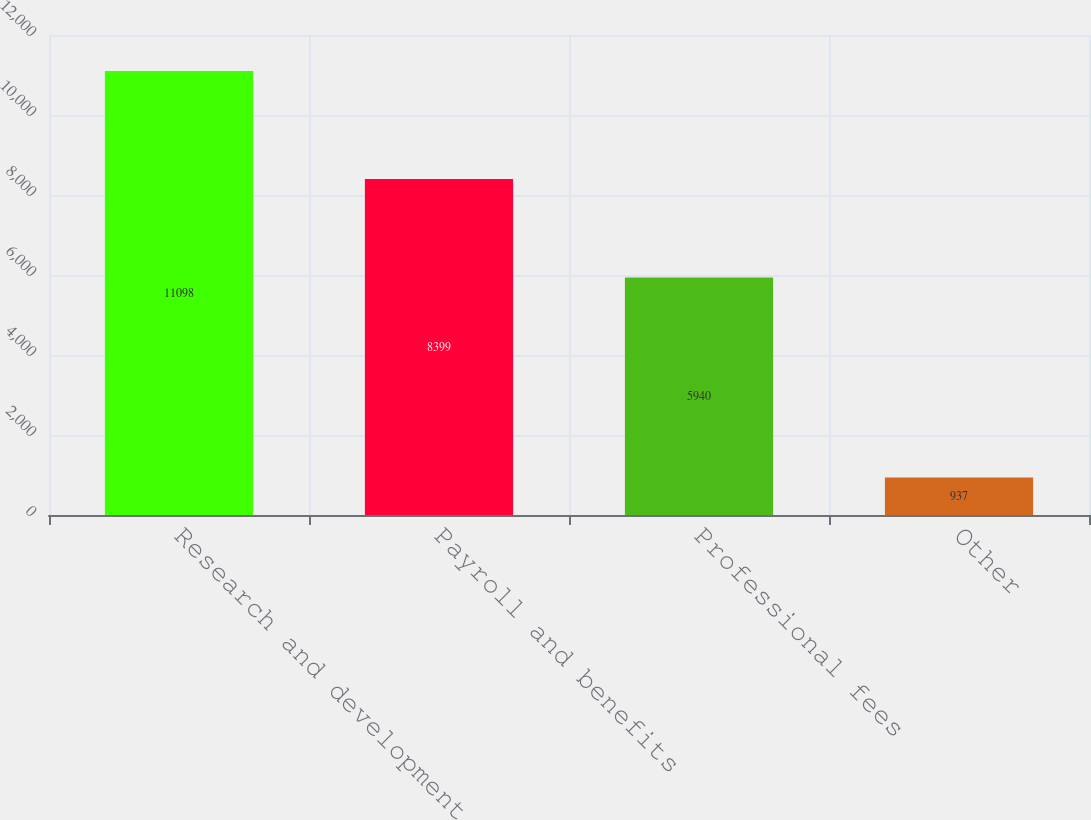Convert chart. <chart><loc_0><loc_0><loc_500><loc_500><bar_chart><fcel>Research and development<fcel>Payroll and benefits<fcel>Professional fees<fcel>Other<nl><fcel>11098<fcel>8399<fcel>5940<fcel>937<nl></chart> 